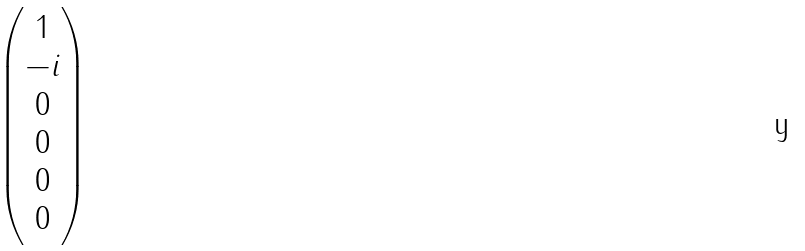Convert formula to latex. <formula><loc_0><loc_0><loc_500><loc_500>\begin{pmatrix} 1 \\ - i \\ 0 \\ 0 \\ 0 \\ 0 \end{pmatrix}</formula> 